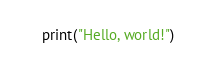Convert code to text. <code><loc_0><loc_0><loc_500><loc_500><_Python_>    print("Hello, world!")
</code> 